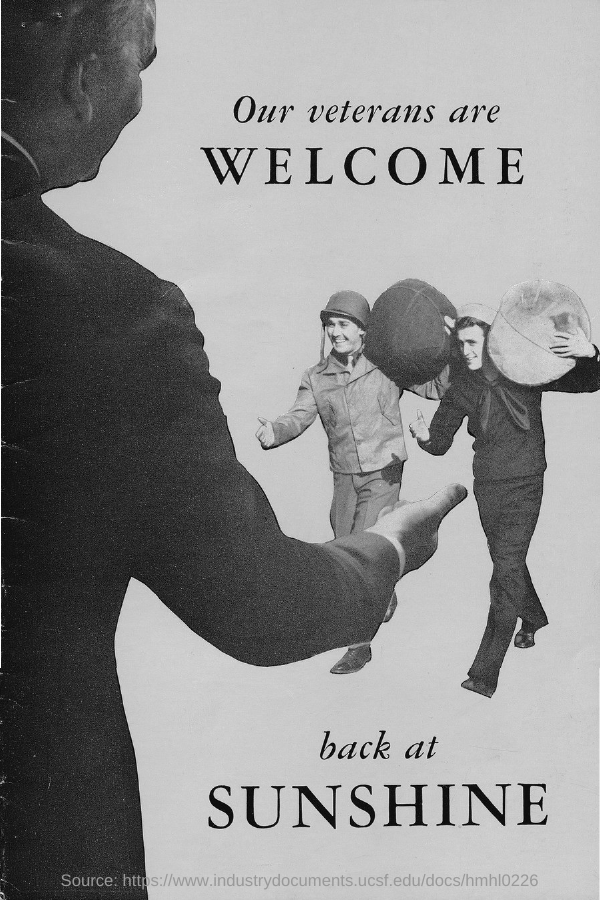What is the title of the document?
Give a very brief answer. Our veterans are welcome. 